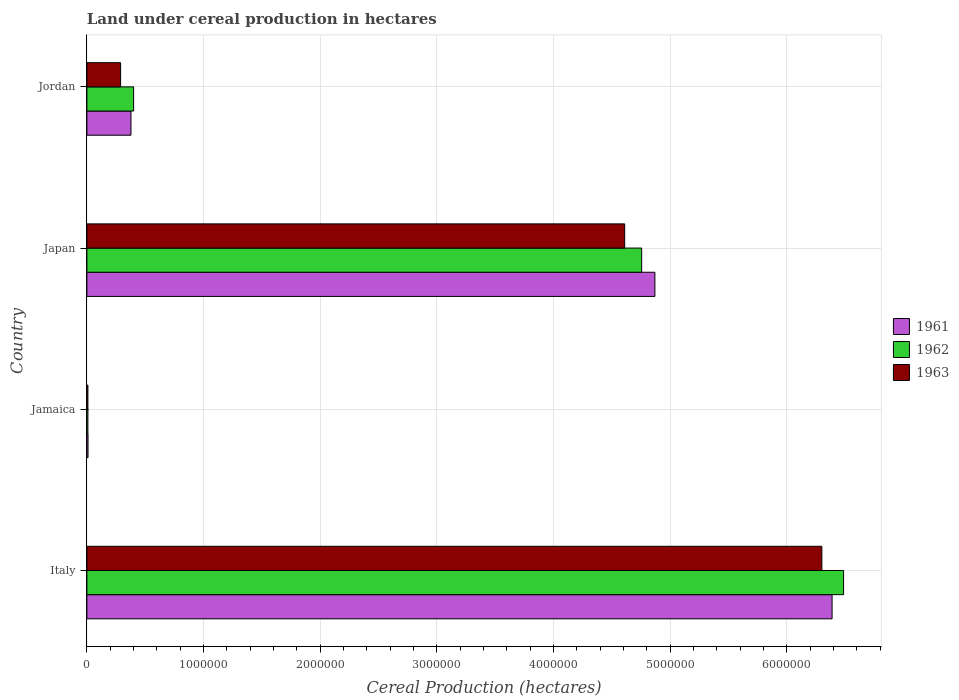How many bars are there on the 4th tick from the top?
Your answer should be very brief. 3. What is the label of the 2nd group of bars from the top?
Your response must be concise. Japan. In how many cases, is the number of bars for a given country not equal to the number of legend labels?
Your answer should be compact. 0. What is the land under cereal production in 1963 in Jamaica?
Provide a short and direct response. 8619. Across all countries, what is the maximum land under cereal production in 1963?
Your answer should be compact. 6.30e+06. Across all countries, what is the minimum land under cereal production in 1961?
Provide a short and direct response. 9712. In which country was the land under cereal production in 1961 minimum?
Make the answer very short. Jamaica. What is the total land under cereal production in 1962 in the graph?
Your answer should be very brief. 1.17e+07. What is the difference between the land under cereal production in 1962 in Japan and that in Jordan?
Make the answer very short. 4.35e+06. What is the difference between the land under cereal production in 1962 in Italy and the land under cereal production in 1961 in Jordan?
Your response must be concise. 6.11e+06. What is the average land under cereal production in 1961 per country?
Your answer should be compact. 2.91e+06. What is the difference between the land under cereal production in 1962 and land under cereal production in 1961 in Japan?
Provide a short and direct response. -1.13e+05. What is the ratio of the land under cereal production in 1963 in Italy to that in Japan?
Your answer should be compact. 1.37. What is the difference between the highest and the second highest land under cereal production in 1961?
Give a very brief answer. 1.52e+06. What is the difference between the highest and the lowest land under cereal production in 1961?
Your response must be concise. 6.38e+06. Is the sum of the land under cereal production in 1963 in Japan and Jordan greater than the maximum land under cereal production in 1962 across all countries?
Provide a succinct answer. No. What does the 2nd bar from the top in Japan represents?
Provide a succinct answer. 1962. How many bars are there?
Give a very brief answer. 12. Are all the bars in the graph horizontal?
Offer a terse response. Yes. What is the difference between two consecutive major ticks on the X-axis?
Give a very brief answer. 1.00e+06. Does the graph contain grids?
Provide a short and direct response. Yes. Where does the legend appear in the graph?
Your response must be concise. Center right. How many legend labels are there?
Ensure brevity in your answer.  3. What is the title of the graph?
Make the answer very short. Land under cereal production in hectares. What is the label or title of the X-axis?
Ensure brevity in your answer.  Cereal Production (hectares). What is the Cereal Production (hectares) in 1961 in Italy?
Make the answer very short. 6.39e+06. What is the Cereal Production (hectares) in 1962 in Italy?
Offer a very short reply. 6.49e+06. What is the Cereal Production (hectares) of 1963 in Italy?
Your response must be concise. 6.30e+06. What is the Cereal Production (hectares) in 1961 in Jamaica?
Give a very brief answer. 9712. What is the Cereal Production (hectares) of 1962 in Jamaica?
Offer a terse response. 8579. What is the Cereal Production (hectares) in 1963 in Jamaica?
Make the answer very short. 8619. What is the Cereal Production (hectares) in 1961 in Japan?
Keep it short and to the point. 4.87e+06. What is the Cereal Production (hectares) of 1962 in Japan?
Offer a very short reply. 4.76e+06. What is the Cereal Production (hectares) in 1963 in Japan?
Your answer should be compact. 4.61e+06. What is the Cereal Production (hectares) of 1961 in Jordan?
Provide a short and direct response. 3.78e+05. What is the Cereal Production (hectares) in 1962 in Jordan?
Provide a succinct answer. 4.01e+05. What is the Cereal Production (hectares) of 1963 in Jordan?
Offer a terse response. 2.89e+05. Across all countries, what is the maximum Cereal Production (hectares) of 1961?
Keep it short and to the point. 6.39e+06. Across all countries, what is the maximum Cereal Production (hectares) in 1962?
Make the answer very short. 6.49e+06. Across all countries, what is the maximum Cereal Production (hectares) in 1963?
Your answer should be very brief. 6.30e+06. Across all countries, what is the minimum Cereal Production (hectares) in 1961?
Your response must be concise. 9712. Across all countries, what is the minimum Cereal Production (hectares) in 1962?
Make the answer very short. 8579. Across all countries, what is the minimum Cereal Production (hectares) of 1963?
Ensure brevity in your answer.  8619. What is the total Cereal Production (hectares) in 1961 in the graph?
Offer a very short reply. 1.16e+07. What is the total Cereal Production (hectares) of 1962 in the graph?
Your answer should be compact. 1.17e+07. What is the total Cereal Production (hectares) in 1963 in the graph?
Provide a succinct answer. 1.12e+07. What is the difference between the Cereal Production (hectares) of 1961 in Italy and that in Jamaica?
Your response must be concise. 6.38e+06. What is the difference between the Cereal Production (hectares) in 1962 in Italy and that in Jamaica?
Make the answer very short. 6.48e+06. What is the difference between the Cereal Production (hectares) in 1963 in Italy and that in Jamaica?
Give a very brief answer. 6.29e+06. What is the difference between the Cereal Production (hectares) of 1961 in Italy and that in Japan?
Your response must be concise. 1.52e+06. What is the difference between the Cereal Production (hectares) in 1962 in Italy and that in Japan?
Offer a very short reply. 1.73e+06. What is the difference between the Cereal Production (hectares) of 1963 in Italy and that in Japan?
Provide a short and direct response. 1.69e+06. What is the difference between the Cereal Production (hectares) in 1961 in Italy and that in Jordan?
Your response must be concise. 6.01e+06. What is the difference between the Cereal Production (hectares) in 1962 in Italy and that in Jordan?
Provide a succinct answer. 6.09e+06. What is the difference between the Cereal Production (hectares) in 1963 in Italy and that in Jordan?
Provide a succinct answer. 6.01e+06. What is the difference between the Cereal Production (hectares) of 1961 in Jamaica and that in Japan?
Ensure brevity in your answer.  -4.86e+06. What is the difference between the Cereal Production (hectares) in 1962 in Jamaica and that in Japan?
Keep it short and to the point. -4.75e+06. What is the difference between the Cereal Production (hectares) in 1963 in Jamaica and that in Japan?
Offer a very short reply. -4.60e+06. What is the difference between the Cereal Production (hectares) in 1961 in Jamaica and that in Jordan?
Make the answer very short. -3.68e+05. What is the difference between the Cereal Production (hectares) in 1962 in Jamaica and that in Jordan?
Keep it short and to the point. -3.92e+05. What is the difference between the Cereal Production (hectares) in 1963 in Jamaica and that in Jordan?
Provide a short and direct response. -2.80e+05. What is the difference between the Cereal Production (hectares) in 1961 in Japan and that in Jordan?
Offer a very short reply. 4.49e+06. What is the difference between the Cereal Production (hectares) in 1962 in Japan and that in Jordan?
Make the answer very short. 4.35e+06. What is the difference between the Cereal Production (hectares) of 1963 in Japan and that in Jordan?
Give a very brief answer. 4.32e+06. What is the difference between the Cereal Production (hectares) of 1961 in Italy and the Cereal Production (hectares) of 1962 in Jamaica?
Make the answer very short. 6.38e+06. What is the difference between the Cereal Production (hectares) of 1961 in Italy and the Cereal Production (hectares) of 1963 in Jamaica?
Offer a very short reply. 6.38e+06. What is the difference between the Cereal Production (hectares) of 1962 in Italy and the Cereal Production (hectares) of 1963 in Jamaica?
Your answer should be very brief. 6.48e+06. What is the difference between the Cereal Production (hectares) of 1961 in Italy and the Cereal Production (hectares) of 1962 in Japan?
Offer a very short reply. 1.63e+06. What is the difference between the Cereal Production (hectares) of 1961 in Italy and the Cereal Production (hectares) of 1963 in Japan?
Offer a very short reply. 1.78e+06. What is the difference between the Cereal Production (hectares) of 1962 in Italy and the Cereal Production (hectares) of 1963 in Japan?
Your response must be concise. 1.88e+06. What is the difference between the Cereal Production (hectares) of 1961 in Italy and the Cereal Production (hectares) of 1962 in Jordan?
Keep it short and to the point. 5.99e+06. What is the difference between the Cereal Production (hectares) in 1961 in Italy and the Cereal Production (hectares) in 1963 in Jordan?
Your answer should be very brief. 6.10e+06. What is the difference between the Cereal Production (hectares) of 1962 in Italy and the Cereal Production (hectares) of 1963 in Jordan?
Give a very brief answer. 6.20e+06. What is the difference between the Cereal Production (hectares) of 1961 in Jamaica and the Cereal Production (hectares) of 1962 in Japan?
Your response must be concise. -4.75e+06. What is the difference between the Cereal Production (hectares) of 1961 in Jamaica and the Cereal Production (hectares) of 1963 in Japan?
Your answer should be very brief. -4.60e+06. What is the difference between the Cereal Production (hectares) in 1962 in Jamaica and the Cereal Production (hectares) in 1963 in Japan?
Your response must be concise. -4.60e+06. What is the difference between the Cereal Production (hectares) in 1961 in Jamaica and the Cereal Production (hectares) in 1962 in Jordan?
Offer a very short reply. -3.91e+05. What is the difference between the Cereal Production (hectares) of 1961 in Jamaica and the Cereal Production (hectares) of 1963 in Jordan?
Your answer should be very brief. -2.79e+05. What is the difference between the Cereal Production (hectares) in 1962 in Jamaica and the Cereal Production (hectares) in 1963 in Jordan?
Your answer should be compact. -2.80e+05. What is the difference between the Cereal Production (hectares) of 1961 in Japan and the Cereal Production (hectares) of 1962 in Jordan?
Give a very brief answer. 4.47e+06. What is the difference between the Cereal Production (hectares) in 1961 in Japan and the Cereal Production (hectares) in 1963 in Jordan?
Provide a short and direct response. 4.58e+06. What is the difference between the Cereal Production (hectares) in 1962 in Japan and the Cereal Production (hectares) in 1963 in Jordan?
Offer a very short reply. 4.47e+06. What is the average Cereal Production (hectares) of 1961 per country?
Your answer should be compact. 2.91e+06. What is the average Cereal Production (hectares) in 1962 per country?
Provide a succinct answer. 2.91e+06. What is the average Cereal Production (hectares) of 1963 per country?
Provide a succinct answer. 2.80e+06. What is the difference between the Cereal Production (hectares) of 1961 and Cereal Production (hectares) of 1962 in Italy?
Keep it short and to the point. -9.87e+04. What is the difference between the Cereal Production (hectares) in 1961 and Cereal Production (hectares) in 1963 in Italy?
Offer a very short reply. 8.77e+04. What is the difference between the Cereal Production (hectares) of 1962 and Cereal Production (hectares) of 1963 in Italy?
Keep it short and to the point. 1.86e+05. What is the difference between the Cereal Production (hectares) of 1961 and Cereal Production (hectares) of 1962 in Jamaica?
Offer a terse response. 1133. What is the difference between the Cereal Production (hectares) in 1961 and Cereal Production (hectares) in 1963 in Jamaica?
Provide a succinct answer. 1093. What is the difference between the Cereal Production (hectares) of 1961 and Cereal Production (hectares) of 1962 in Japan?
Keep it short and to the point. 1.13e+05. What is the difference between the Cereal Production (hectares) of 1961 and Cereal Production (hectares) of 1963 in Japan?
Your answer should be very brief. 2.59e+05. What is the difference between the Cereal Production (hectares) in 1962 and Cereal Production (hectares) in 1963 in Japan?
Provide a short and direct response. 1.46e+05. What is the difference between the Cereal Production (hectares) in 1961 and Cereal Production (hectares) in 1962 in Jordan?
Make the answer very short. -2.28e+04. What is the difference between the Cereal Production (hectares) of 1961 and Cereal Production (hectares) of 1963 in Jordan?
Your answer should be very brief. 8.87e+04. What is the difference between the Cereal Production (hectares) of 1962 and Cereal Production (hectares) of 1963 in Jordan?
Your response must be concise. 1.12e+05. What is the ratio of the Cereal Production (hectares) in 1961 in Italy to that in Jamaica?
Your answer should be compact. 657.66. What is the ratio of the Cereal Production (hectares) of 1962 in Italy to that in Jamaica?
Offer a very short reply. 756.02. What is the ratio of the Cereal Production (hectares) in 1963 in Italy to that in Jamaica?
Provide a short and direct response. 730.88. What is the ratio of the Cereal Production (hectares) in 1961 in Italy to that in Japan?
Provide a succinct answer. 1.31. What is the ratio of the Cereal Production (hectares) of 1962 in Italy to that in Japan?
Give a very brief answer. 1.36. What is the ratio of the Cereal Production (hectares) of 1963 in Italy to that in Japan?
Your response must be concise. 1.37. What is the ratio of the Cereal Production (hectares) in 1961 in Italy to that in Jordan?
Your answer should be very brief. 16.91. What is the ratio of the Cereal Production (hectares) of 1962 in Italy to that in Jordan?
Your answer should be very brief. 16.19. What is the ratio of the Cereal Production (hectares) of 1963 in Italy to that in Jordan?
Your answer should be compact. 21.79. What is the ratio of the Cereal Production (hectares) of 1961 in Jamaica to that in Japan?
Your answer should be compact. 0. What is the ratio of the Cereal Production (hectares) in 1962 in Jamaica to that in Japan?
Provide a succinct answer. 0. What is the ratio of the Cereal Production (hectares) of 1963 in Jamaica to that in Japan?
Keep it short and to the point. 0. What is the ratio of the Cereal Production (hectares) of 1961 in Jamaica to that in Jordan?
Your answer should be compact. 0.03. What is the ratio of the Cereal Production (hectares) in 1962 in Jamaica to that in Jordan?
Make the answer very short. 0.02. What is the ratio of the Cereal Production (hectares) of 1963 in Jamaica to that in Jordan?
Make the answer very short. 0.03. What is the ratio of the Cereal Production (hectares) of 1961 in Japan to that in Jordan?
Make the answer very short. 12.89. What is the ratio of the Cereal Production (hectares) of 1962 in Japan to that in Jordan?
Provide a succinct answer. 11.87. What is the ratio of the Cereal Production (hectares) in 1963 in Japan to that in Jordan?
Offer a very short reply. 15.95. What is the difference between the highest and the second highest Cereal Production (hectares) in 1961?
Offer a terse response. 1.52e+06. What is the difference between the highest and the second highest Cereal Production (hectares) of 1962?
Your answer should be very brief. 1.73e+06. What is the difference between the highest and the second highest Cereal Production (hectares) of 1963?
Ensure brevity in your answer.  1.69e+06. What is the difference between the highest and the lowest Cereal Production (hectares) of 1961?
Ensure brevity in your answer.  6.38e+06. What is the difference between the highest and the lowest Cereal Production (hectares) of 1962?
Ensure brevity in your answer.  6.48e+06. What is the difference between the highest and the lowest Cereal Production (hectares) of 1963?
Your answer should be very brief. 6.29e+06. 